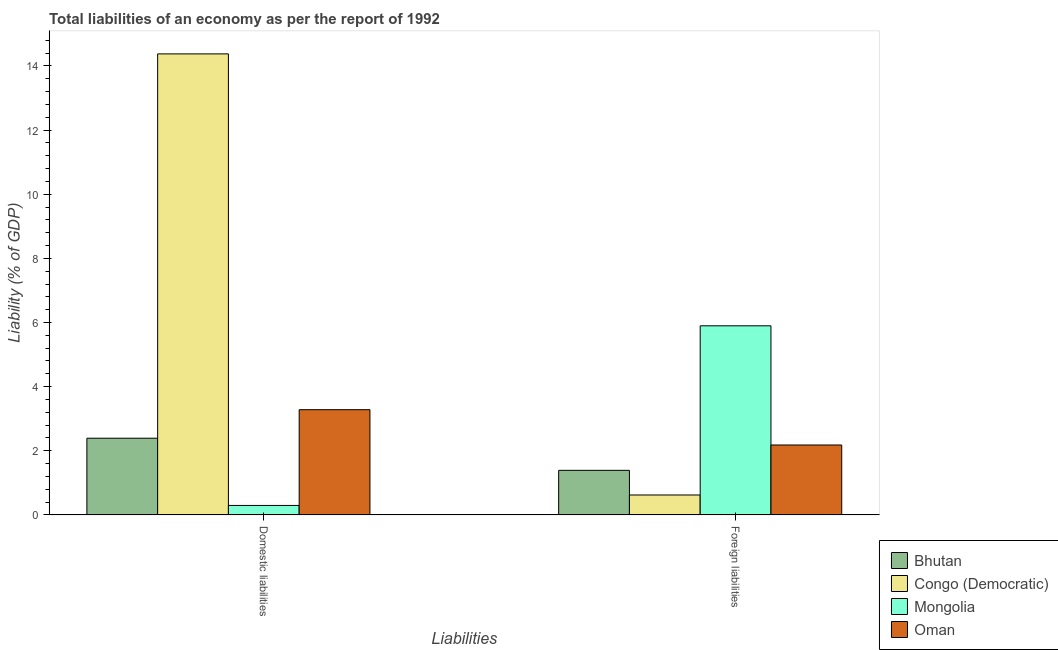Are the number of bars on each tick of the X-axis equal?
Provide a short and direct response. Yes. What is the label of the 2nd group of bars from the left?
Give a very brief answer. Foreign liabilities. What is the incurrence of foreign liabilities in Congo (Democratic)?
Offer a very short reply. 0.62. Across all countries, what is the maximum incurrence of foreign liabilities?
Provide a succinct answer. 5.9. Across all countries, what is the minimum incurrence of domestic liabilities?
Ensure brevity in your answer.  0.3. In which country was the incurrence of foreign liabilities maximum?
Provide a succinct answer. Mongolia. In which country was the incurrence of domestic liabilities minimum?
Your response must be concise. Mongolia. What is the total incurrence of foreign liabilities in the graph?
Your answer should be very brief. 10.09. What is the difference between the incurrence of foreign liabilities in Oman and that in Congo (Democratic)?
Provide a succinct answer. 1.56. What is the difference between the incurrence of domestic liabilities in Congo (Democratic) and the incurrence of foreign liabilities in Mongolia?
Your answer should be very brief. 8.48. What is the average incurrence of foreign liabilities per country?
Ensure brevity in your answer.  2.52. What is the difference between the incurrence of foreign liabilities and incurrence of domestic liabilities in Mongolia?
Give a very brief answer. 5.6. In how many countries, is the incurrence of domestic liabilities greater than 14.4 %?
Your answer should be very brief. 0. What is the ratio of the incurrence of domestic liabilities in Congo (Democratic) to that in Bhutan?
Your answer should be compact. 6.01. In how many countries, is the incurrence of domestic liabilities greater than the average incurrence of domestic liabilities taken over all countries?
Give a very brief answer. 1. What does the 4th bar from the left in Domestic liabilities represents?
Your response must be concise. Oman. What does the 2nd bar from the right in Foreign liabilities represents?
Your response must be concise. Mongolia. How many bars are there?
Keep it short and to the point. 8. Are all the bars in the graph horizontal?
Offer a terse response. No. How many countries are there in the graph?
Your answer should be compact. 4. What is the difference between two consecutive major ticks on the Y-axis?
Provide a short and direct response. 2. Are the values on the major ticks of Y-axis written in scientific E-notation?
Keep it short and to the point. No. Does the graph contain grids?
Keep it short and to the point. No. Where does the legend appear in the graph?
Your answer should be compact. Bottom right. How many legend labels are there?
Keep it short and to the point. 4. What is the title of the graph?
Keep it short and to the point. Total liabilities of an economy as per the report of 1992. Does "Qatar" appear as one of the legend labels in the graph?
Your answer should be very brief. No. What is the label or title of the X-axis?
Your answer should be compact. Liabilities. What is the label or title of the Y-axis?
Provide a short and direct response. Liability (% of GDP). What is the Liability (% of GDP) in Bhutan in Domestic liabilities?
Make the answer very short. 2.39. What is the Liability (% of GDP) of Congo (Democratic) in Domestic liabilities?
Provide a short and direct response. 14.38. What is the Liability (% of GDP) in Mongolia in Domestic liabilities?
Offer a terse response. 0.3. What is the Liability (% of GDP) of Oman in Domestic liabilities?
Ensure brevity in your answer.  3.28. What is the Liability (% of GDP) in Bhutan in Foreign liabilities?
Your answer should be compact. 1.39. What is the Liability (% of GDP) in Congo (Democratic) in Foreign liabilities?
Provide a succinct answer. 0.62. What is the Liability (% of GDP) in Mongolia in Foreign liabilities?
Offer a terse response. 5.9. What is the Liability (% of GDP) of Oman in Foreign liabilities?
Your answer should be very brief. 2.18. Across all Liabilities, what is the maximum Liability (% of GDP) in Bhutan?
Offer a very short reply. 2.39. Across all Liabilities, what is the maximum Liability (% of GDP) in Congo (Democratic)?
Provide a short and direct response. 14.38. Across all Liabilities, what is the maximum Liability (% of GDP) of Mongolia?
Provide a succinct answer. 5.9. Across all Liabilities, what is the maximum Liability (% of GDP) of Oman?
Your response must be concise. 3.28. Across all Liabilities, what is the minimum Liability (% of GDP) in Bhutan?
Provide a succinct answer. 1.39. Across all Liabilities, what is the minimum Liability (% of GDP) in Congo (Democratic)?
Offer a terse response. 0.62. Across all Liabilities, what is the minimum Liability (% of GDP) of Mongolia?
Offer a very short reply. 0.3. Across all Liabilities, what is the minimum Liability (% of GDP) in Oman?
Offer a very short reply. 2.18. What is the total Liability (% of GDP) of Bhutan in the graph?
Provide a short and direct response. 3.78. What is the total Liability (% of GDP) in Congo (Democratic) in the graph?
Your answer should be compact. 15. What is the total Liability (% of GDP) of Mongolia in the graph?
Keep it short and to the point. 6.19. What is the total Liability (% of GDP) of Oman in the graph?
Provide a short and direct response. 5.46. What is the difference between the Liability (% of GDP) in Bhutan in Domestic liabilities and that in Foreign liabilities?
Keep it short and to the point. 1. What is the difference between the Liability (% of GDP) of Congo (Democratic) in Domestic liabilities and that in Foreign liabilities?
Provide a short and direct response. 13.75. What is the difference between the Liability (% of GDP) in Mongolia in Domestic liabilities and that in Foreign liabilities?
Your response must be concise. -5.6. What is the difference between the Liability (% of GDP) of Oman in Domestic liabilities and that in Foreign liabilities?
Make the answer very short. 1.1. What is the difference between the Liability (% of GDP) of Bhutan in Domestic liabilities and the Liability (% of GDP) of Congo (Democratic) in Foreign liabilities?
Provide a short and direct response. 1.77. What is the difference between the Liability (% of GDP) of Bhutan in Domestic liabilities and the Liability (% of GDP) of Mongolia in Foreign liabilities?
Give a very brief answer. -3.5. What is the difference between the Liability (% of GDP) of Bhutan in Domestic liabilities and the Liability (% of GDP) of Oman in Foreign liabilities?
Keep it short and to the point. 0.21. What is the difference between the Liability (% of GDP) of Congo (Democratic) in Domestic liabilities and the Liability (% of GDP) of Mongolia in Foreign liabilities?
Make the answer very short. 8.48. What is the difference between the Liability (% of GDP) of Congo (Democratic) in Domestic liabilities and the Liability (% of GDP) of Oman in Foreign liabilities?
Your answer should be very brief. 12.19. What is the difference between the Liability (% of GDP) of Mongolia in Domestic liabilities and the Liability (% of GDP) of Oman in Foreign liabilities?
Provide a succinct answer. -1.88. What is the average Liability (% of GDP) in Bhutan per Liabilities?
Keep it short and to the point. 1.89. What is the average Liability (% of GDP) of Congo (Democratic) per Liabilities?
Give a very brief answer. 7.5. What is the average Liability (% of GDP) in Mongolia per Liabilities?
Make the answer very short. 3.1. What is the average Liability (% of GDP) in Oman per Liabilities?
Offer a very short reply. 2.73. What is the difference between the Liability (% of GDP) of Bhutan and Liability (% of GDP) of Congo (Democratic) in Domestic liabilities?
Ensure brevity in your answer.  -11.98. What is the difference between the Liability (% of GDP) in Bhutan and Liability (% of GDP) in Mongolia in Domestic liabilities?
Make the answer very short. 2.1. What is the difference between the Liability (% of GDP) in Bhutan and Liability (% of GDP) in Oman in Domestic liabilities?
Offer a very short reply. -0.89. What is the difference between the Liability (% of GDP) in Congo (Democratic) and Liability (% of GDP) in Mongolia in Domestic liabilities?
Ensure brevity in your answer.  14.08. What is the difference between the Liability (% of GDP) of Congo (Democratic) and Liability (% of GDP) of Oman in Domestic liabilities?
Ensure brevity in your answer.  11.09. What is the difference between the Liability (% of GDP) in Mongolia and Liability (% of GDP) in Oman in Domestic liabilities?
Make the answer very short. -2.99. What is the difference between the Liability (% of GDP) in Bhutan and Liability (% of GDP) in Congo (Democratic) in Foreign liabilities?
Provide a succinct answer. 0.77. What is the difference between the Liability (% of GDP) of Bhutan and Liability (% of GDP) of Mongolia in Foreign liabilities?
Ensure brevity in your answer.  -4.51. What is the difference between the Liability (% of GDP) of Bhutan and Liability (% of GDP) of Oman in Foreign liabilities?
Keep it short and to the point. -0.79. What is the difference between the Liability (% of GDP) in Congo (Democratic) and Liability (% of GDP) in Mongolia in Foreign liabilities?
Your answer should be compact. -5.28. What is the difference between the Liability (% of GDP) of Congo (Democratic) and Liability (% of GDP) of Oman in Foreign liabilities?
Offer a very short reply. -1.56. What is the difference between the Liability (% of GDP) of Mongolia and Liability (% of GDP) of Oman in Foreign liabilities?
Keep it short and to the point. 3.72. What is the ratio of the Liability (% of GDP) of Bhutan in Domestic liabilities to that in Foreign liabilities?
Make the answer very short. 1.72. What is the ratio of the Liability (% of GDP) in Congo (Democratic) in Domestic liabilities to that in Foreign liabilities?
Provide a short and direct response. 23.13. What is the ratio of the Liability (% of GDP) in Mongolia in Domestic liabilities to that in Foreign liabilities?
Your response must be concise. 0.05. What is the ratio of the Liability (% of GDP) in Oman in Domestic liabilities to that in Foreign liabilities?
Your answer should be very brief. 1.5. What is the difference between the highest and the second highest Liability (% of GDP) in Bhutan?
Your answer should be very brief. 1. What is the difference between the highest and the second highest Liability (% of GDP) in Congo (Democratic)?
Give a very brief answer. 13.75. What is the difference between the highest and the second highest Liability (% of GDP) of Mongolia?
Offer a very short reply. 5.6. What is the difference between the highest and the second highest Liability (% of GDP) of Oman?
Make the answer very short. 1.1. What is the difference between the highest and the lowest Liability (% of GDP) of Congo (Democratic)?
Offer a terse response. 13.75. What is the difference between the highest and the lowest Liability (% of GDP) in Mongolia?
Offer a very short reply. 5.6. What is the difference between the highest and the lowest Liability (% of GDP) of Oman?
Offer a terse response. 1.1. 